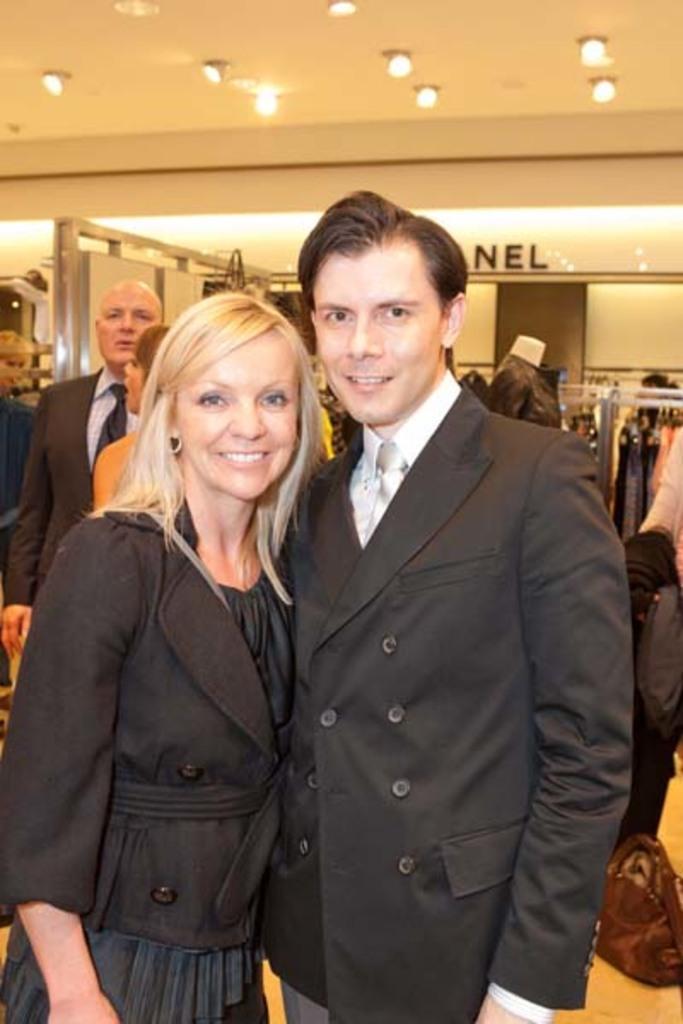How would you summarize this image in a sentence or two? This picture is clicked inside the hall. In the foreground we can see a man and woman wearing blazers, smiling and standing on the ground. At the top there is a roof and the ceiling lights. In the background we can see the clothes hanging on the metal rods with the help of the hangers and we can see the group of people standing on the ground and a bag is placed on the ground and we can see a mannequin wearing clothes and standing. In the background we can see the text on the wall and we can see some other objects. 